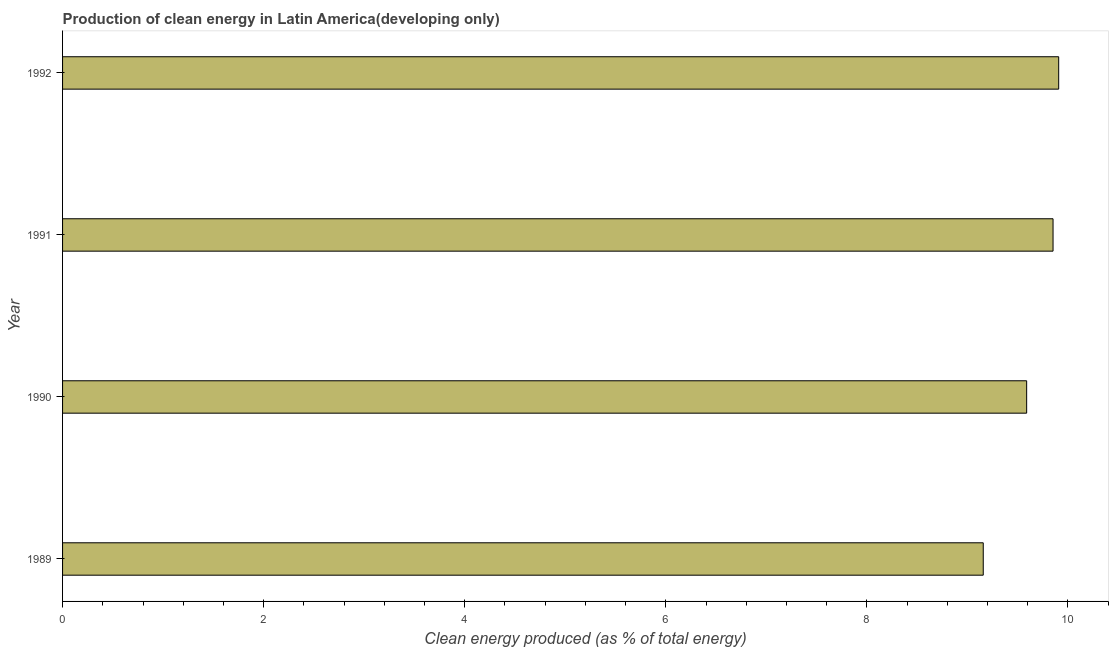Does the graph contain any zero values?
Your answer should be compact. No. What is the title of the graph?
Provide a succinct answer. Production of clean energy in Latin America(developing only). What is the label or title of the X-axis?
Offer a very short reply. Clean energy produced (as % of total energy). What is the label or title of the Y-axis?
Make the answer very short. Year. What is the production of clean energy in 1991?
Provide a short and direct response. 9.85. Across all years, what is the maximum production of clean energy?
Provide a short and direct response. 9.91. Across all years, what is the minimum production of clean energy?
Your response must be concise. 9.16. In which year was the production of clean energy minimum?
Your answer should be compact. 1989. What is the sum of the production of clean energy?
Offer a terse response. 38.51. What is the difference between the production of clean energy in 1989 and 1992?
Offer a very short reply. -0.75. What is the average production of clean energy per year?
Give a very brief answer. 9.63. What is the median production of clean energy?
Provide a succinct answer. 9.72. In how many years, is the production of clean energy greater than 2 %?
Your response must be concise. 4. Do a majority of the years between 1990 and 1992 (inclusive) have production of clean energy greater than 7.2 %?
Give a very brief answer. Yes. Is the difference between the production of clean energy in 1990 and 1991 greater than the difference between any two years?
Your response must be concise. No. What is the difference between the highest and the second highest production of clean energy?
Ensure brevity in your answer.  0.06. In how many years, is the production of clean energy greater than the average production of clean energy taken over all years?
Offer a very short reply. 2. How many bars are there?
Your answer should be very brief. 4. Are all the bars in the graph horizontal?
Keep it short and to the point. Yes. Are the values on the major ticks of X-axis written in scientific E-notation?
Offer a terse response. No. What is the Clean energy produced (as % of total energy) of 1989?
Offer a very short reply. 9.16. What is the Clean energy produced (as % of total energy) in 1990?
Give a very brief answer. 9.59. What is the Clean energy produced (as % of total energy) of 1991?
Your response must be concise. 9.85. What is the Clean energy produced (as % of total energy) of 1992?
Offer a terse response. 9.91. What is the difference between the Clean energy produced (as % of total energy) in 1989 and 1990?
Give a very brief answer. -0.43. What is the difference between the Clean energy produced (as % of total energy) in 1989 and 1991?
Keep it short and to the point. -0.69. What is the difference between the Clean energy produced (as % of total energy) in 1989 and 1992?
Give a very brief answer. -0.75. What is the difference between the Clean energy produced (as % of total energy) in 1990 and 1991?
Offer a very short reply. -0.26. What is the difference between the Clean energy produced (as % of total energy) in 1990 and 1992?
Ensure brevity in your answer.  -0.32. What is the difference between the Clean energy produced (as % of total energy) in 1991 and 1992?
Your response must be concise. -0.06. What is the ratio of the Clean energy produced (as % of total energy) in 1989 to that in 1990?
Your answer should be very brief. 0.95. What is the ratio of the Clean energy produced (as % of total energy) in 1989 to that in 1991?
Your answer should be very brief. 0.93. What is the ratio of the Clean energy produced (as % of total energy) in 1989 to that in 1992?
Your response must be concise. 0.92. What is the ratio of the Clean energy produced (as % of total energy) in 1990 to that in 1992?
Your answer should be very brief. 0.97. 